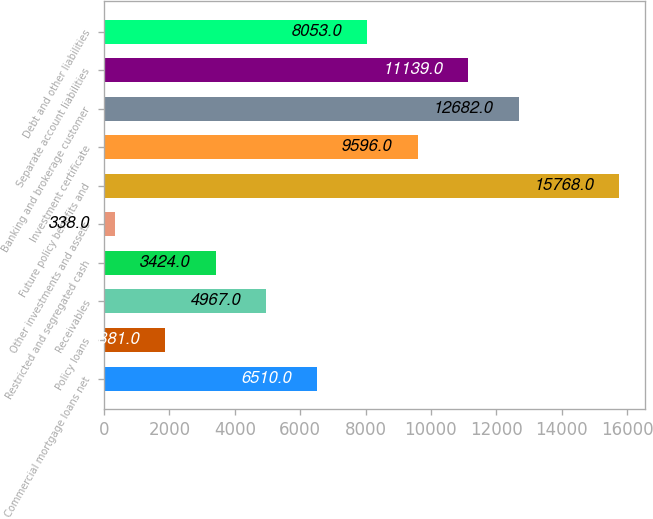Convert chart to OTSL. <chart><loc_0><loc_0><loc_500><loc_500><bar_chart><fcel>Commercial mortgage loans net<fcel>Policy loans<fcel>Receivables<fcel>Restricted and segregated cash<fcel>Other investments and assets<fcel>Future policy benefits and<fcel>Investment certificate<fcel>Banking and brokerage customer<fcel>Separate account liabilities<fcel>Debt and other liabilities<nl><fcel>6510<fcel>1881<fcel>4967<fcel>3424<fcel>338<fcel>15768<fcel>9596<fcel>12682<fcel>11139<fcel>8053<nl></chart> 